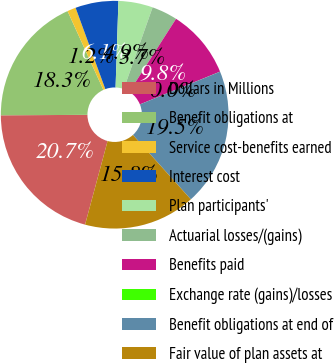Convert chart to OTSL. <chart><loc_0><loc_0><loc_500><loc_500><pie_chart><fcel>Dollars in Millions<fcel>Benefit obligations at<fcel>Service cost-benefits earned<fcel>Interest cost<fcel>Plan participants'<fcel>Actuarial losses/(gains)<fcel>Benefits paid<fcel>Exchange rate (gains)/losses<fcel>Benefit obligations at end of<fcel>Fair value of plan assets at<nl><fcel>20.73%<fcel>18.29%<fcel>1.22%<fcel>6.1%<fcel>4.88%<fcel>3.66%<fcel>9.76%<fcel>0.01%<fcel>19.51%<fcel>15.85%<nl></chart> 